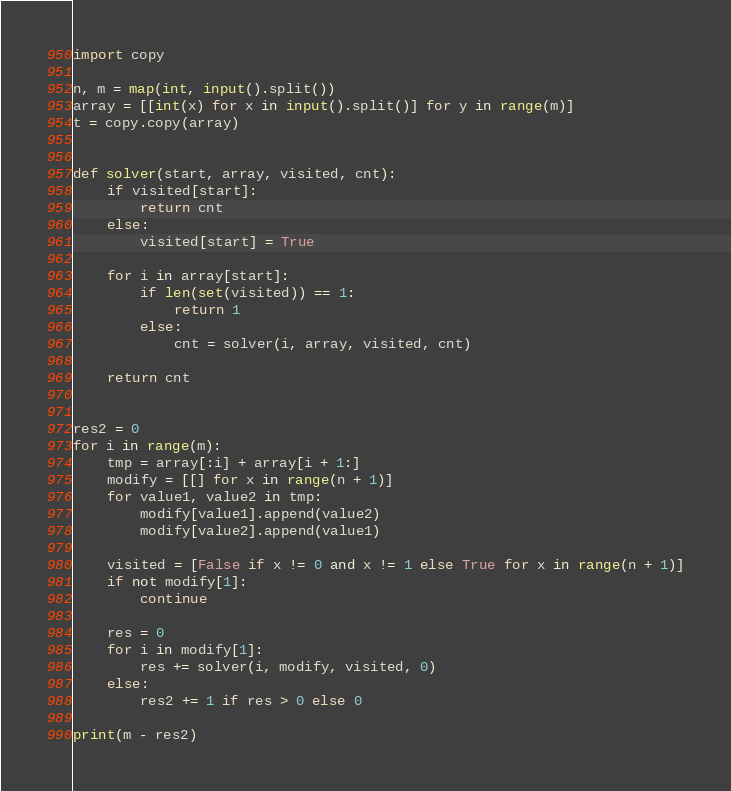<code> <loc_0><loc_0><loc_500><loc_500><_Python_>import copy

n, m = map(int, input().split())
array = [[int(x) for x in input().split()] for y in range(m)]
t = copy.copy(array)


def solver(start, array, visited, cnt):
    if visited[start]:
        return cnt
    else:
        visited[start] = True

    for i in array[start]:
        if len(set(visited)) == 1:
            return 1
        else:
            cnt = solver(i, array, visited, cnt)

    return cnt


res2 = 0
for i in range(m):
    tmp = array[:i] + array[i + 1:]
    modify = [[] for x in range(n + 1)]
    for value1, value2 in tmp:
        modify[value1].append(value2)
        modify[value2].append(value1)

    visited = [False if x != 0 and x != 1 else True for x in range(n + 1)]
    if not modify[1]:
        continue

    res = 0
    for i in modify[1]:
        res += solver(i, modify, visited, 0)
    else:
        res2 += 1 if res > 0 else 0

print(m - res2)
</code> 